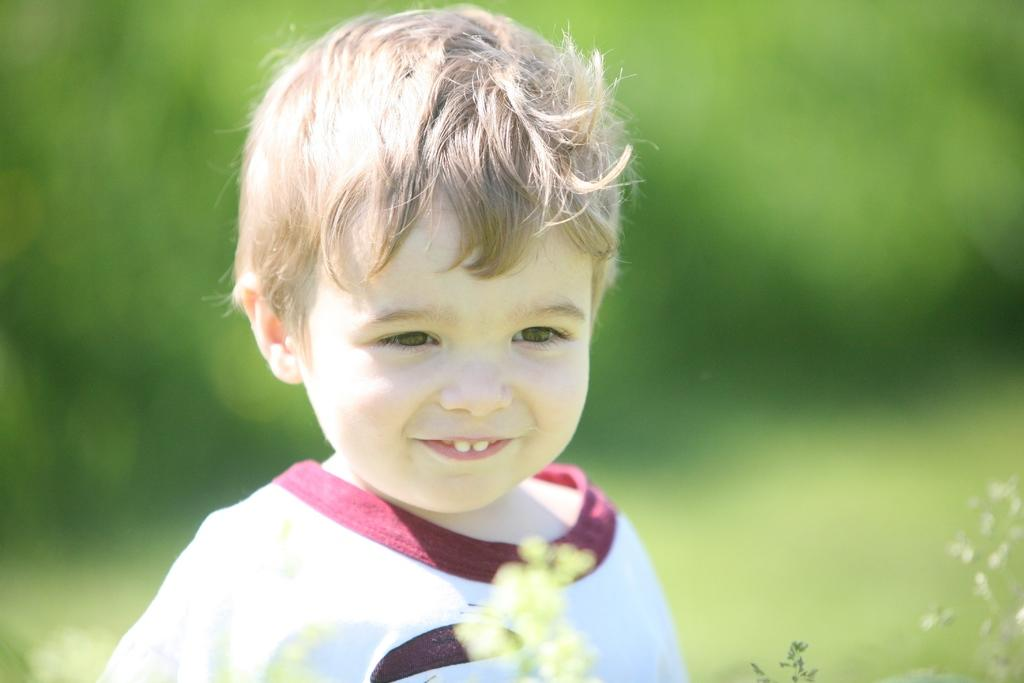What is the main subject of the image? The main subject of the image is a kid. What is the kid's expression in the image? The kid is smiling in the image. What type of vegetation can be seen at the bottom of the image? There are leaves visible at the bottom of the image. How would you describe the background of the image? The background of the image is blurry. Can you tell me how many volcanoes are present in the image? There are no volcanoes present in the image; it features a kid and leaves in the foreground. What type of attention is the kid giving to the volcano in the image? There is no volcano present in the image, so the kid is not giving any attention to it. 